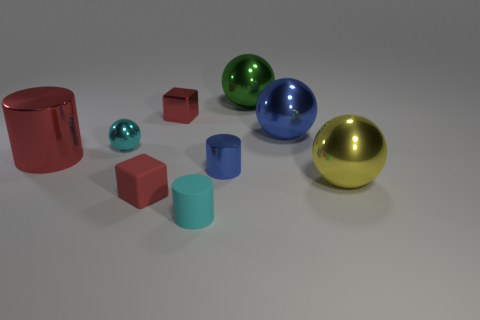How many other things are the same shape as the cyan matte thing?
Offer a terse response. 2. There is a tiny cyan matte thing; does it have the same shape as the small cyan object behind the yellow sphere?
Provide a short and direct response. No. There is another red object that is the same shape as the tiny red metal object; what is its material?
Provide a succinct answer. Rubber. How many small things are either blue balls or red things?
Keep it short and to the point. 2. Is the number of large metal objects on the right side of the small rubber cylinder less than the number of tiny red cubes that are behind the cyan metal thing?
Offer a terse response. No. What number of things are either big brown balls or big metallic balls?
Your answer should be very brief. 3. What number of cyan objects are in front of the large yellow shiny sphere?
Offer a terse response. 1. Does the rubber cylinder have the same color as the tiny metallic cylinder?
Your answer should be compact. No. There is a red object that is made of the same material as the red cylinder; what shape is it?
Provide a succinct answer. Cube. There is a tiny red object behind the large yellow thing; does it have the same shape as the large blue object?
Your answer should be very brief. No. 